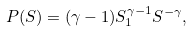<formula> <loc_0><loc_0><loc_500><loc_500>P ( S ) = ( \gamma - 1 ) S _ { 1 } ^ { \gamma - 1 } S ^ { - \gamma } ,</formula> 